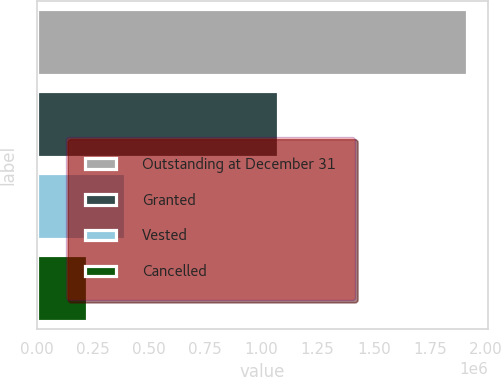<chart> <loc_0><loc_0><loc_500><loc_500><bar_chart><fcel>Outstanding at December 31<fcel>Granted<fcel>Vested<fcel>Cancelled<nl><fcel>1.91353e+06<fcel>1.0738e+06<fcel>395196<fcel>226493<nl></chart> 